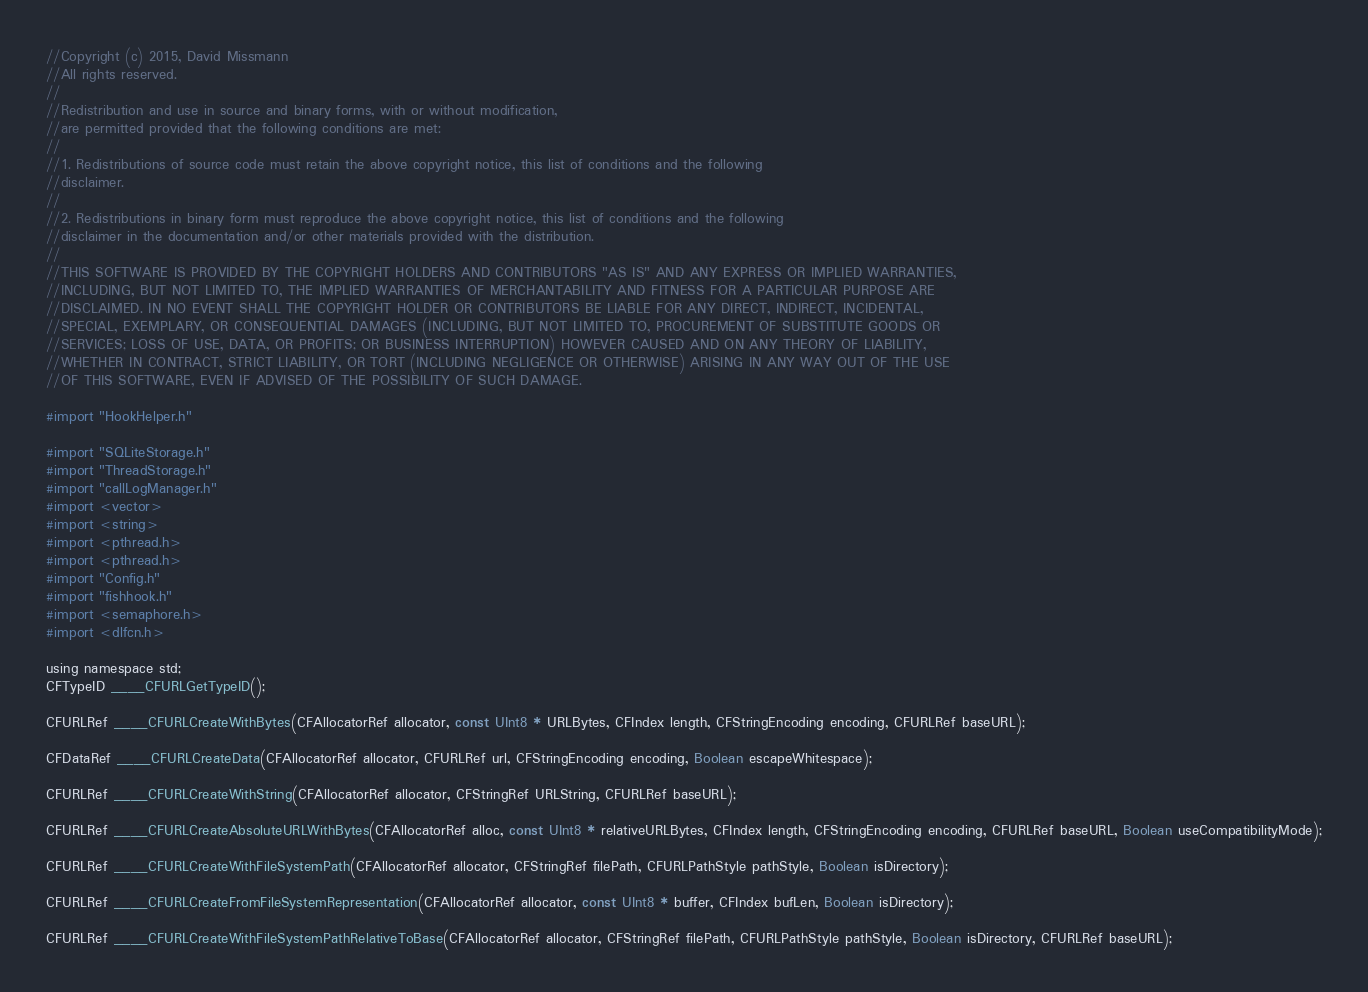Convert code to text. <code><loc_0><loc_0><loc_500><loc_500><_ObjectiveC_>//Copyright (c) 2015, David Missmann
//All rights reserved.
//
//Redistribution and use in source and binary forms, with or without modification,
//are permitted provided that the following conditions are met:
//
//1. Redistributions of source code must retain the above copyright notice, this list of conditions and the following
//disclaimer.
//
//2. Redistributions in binary form must reproduce the above copyright notice, this list of conditions and the following
//disclaimer in the documentation and/or other materials provided with the distribution.
//
//THIS SOFTWARE IS PROVIDED BY THE COPYRIGHT HOLDERS AND CONTRIBUTORS "AS IS" AND ANY EXPRESS OR IMPLIED WARRANTIES,
//INCLUDING, BUT NOT LIMITED TO, THE IMPLIED WARRANTIES OF MERCHANTABILITY AND FITNESS FOR A PARTICULAR PURPOSE ARE
//DISCLAIMED. IN NO EVENT SHALL THE COPYRIGHT HOLDER OR CONTRIBUTORS BE LIABLE FOR ANY DIRECT, INDIRECT, INCIDENTAL,
//SPECIAL, EXEMPLARY, OR CONSEQUENTIAL DAMAGES (INCLUDING, BUT NOT LIMITED TO, PROCUREMENT OF SUBSTITUTE GOODS OR
//SERVICES; LOSS OF USE, DATA, OR PROFITS; OR BUSINESS INTERRUPTION) HOWEVER CAUSED AND ON ANY THEORY OF LIABILITY,
//WHETHER IN CONTRACT, STRICT LIABILITY, OR TORT (INCLUDING NEGLIGENCE OR OTHERWISE) ARISING IN ANY WAY OUT OF THE USE
//OF THIS SOFTWARE, EVEN IF ADVISED OF THE POSSIBILITY OF SUCH DAMAGE.

#import "HookHelper.h"

#import "SQLiteStorage.h"
#import "ThreadStorage.h"
#import "callLogManager.h"
#import <vector>
#import <string>
#import <pthread.h>
#import <pthread.h>
#import "Config.h"
#import "fishhook.h"
#import <semaphore.h>
#import <dlfcn.h>

using namespace std;
CFTypeID ____CFURLGetTypeID();

CFURLRef ____CFURLCreateWithBytes(CFAllocatorRef allocator, const UInt8 * URLBytes, CFIndex length, CFStringEncoding encoding, CFURLRef baseURL);

CFDataRef ____CFURLCreateData(CFAllocatorRef allocator, CFURLRef url, CFStringEncoding encoding, Boolean escapeWhitespace);

CFURLRef ____CFURLCreateWithString(CFAllocatorRef allocator, CFStringRef URLString, CFURLRef baseURL);

CFURLRef ____CFURLCreateAbsoluteURLWithBytes(CFAllocatorRef alloc, const UInt8 * relativeURLBytes, CFIndex length, CFStringEncoding encoding, CFURLRef baseURL, Boolean useCompatibilityMode);

CFURLRef ____CFURLCreateWithFileSystemPath(CFAllocatorRef allocator, CFStringRef filePath, CFURLPathStyle pathStyle, Boolean isDirectory);

CFURLRef ____CFURLCreateFromFileSystemRepresentation(CFAllocatorRef allocator, const UInt8 * buffer, CFIndex bufLen, Boolean isDirectory);

CFURLRef ____CFURLCreateWithFileSystemPathRelativeToBase(CFAllocatorRef allocator, CFStringRef filePath, CFURLPathStyle pathStyle, Boolean isDirectory, CFURLRef baseURL);
</code> 